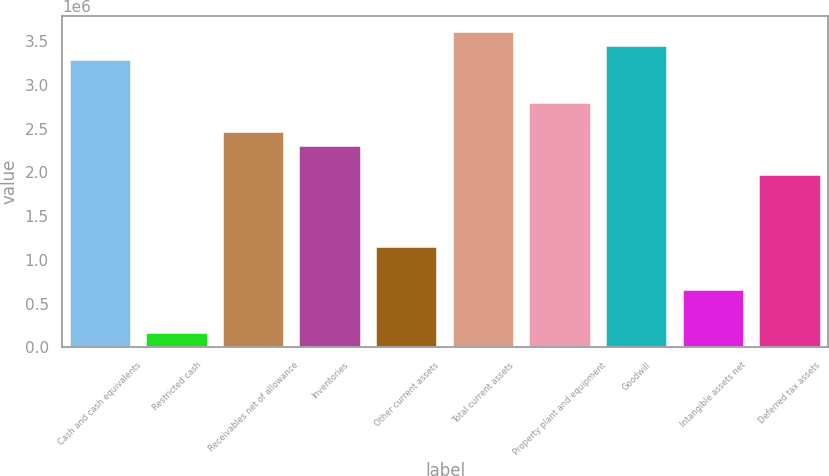Convert chart to OTSL. <chart><loc_0><loc_0><loc_500><loc_500><bar_chart><fcel>Cash and cash equivalents<fcel>Restricted cash<fcel>Receivables net of allowance<fcel>Inventories<fcel>Other current assets<fcel>Total current assets<fcel>Property plant and equipment<fcel>Goodwill<fcel>Intangible assets net<fcel>Deferred tax assets<nl><fcel>3.28152e+06<fcel>165308<fcel>2.46146e+06<fcel>2.29745e+06<fcel>1.14937e+06<fcel>3.60954e+06<fcel>2.78948e+06<fcel>3.44553e+06<fcel>657341<fcel>1.96943e+06<nl></chart> 